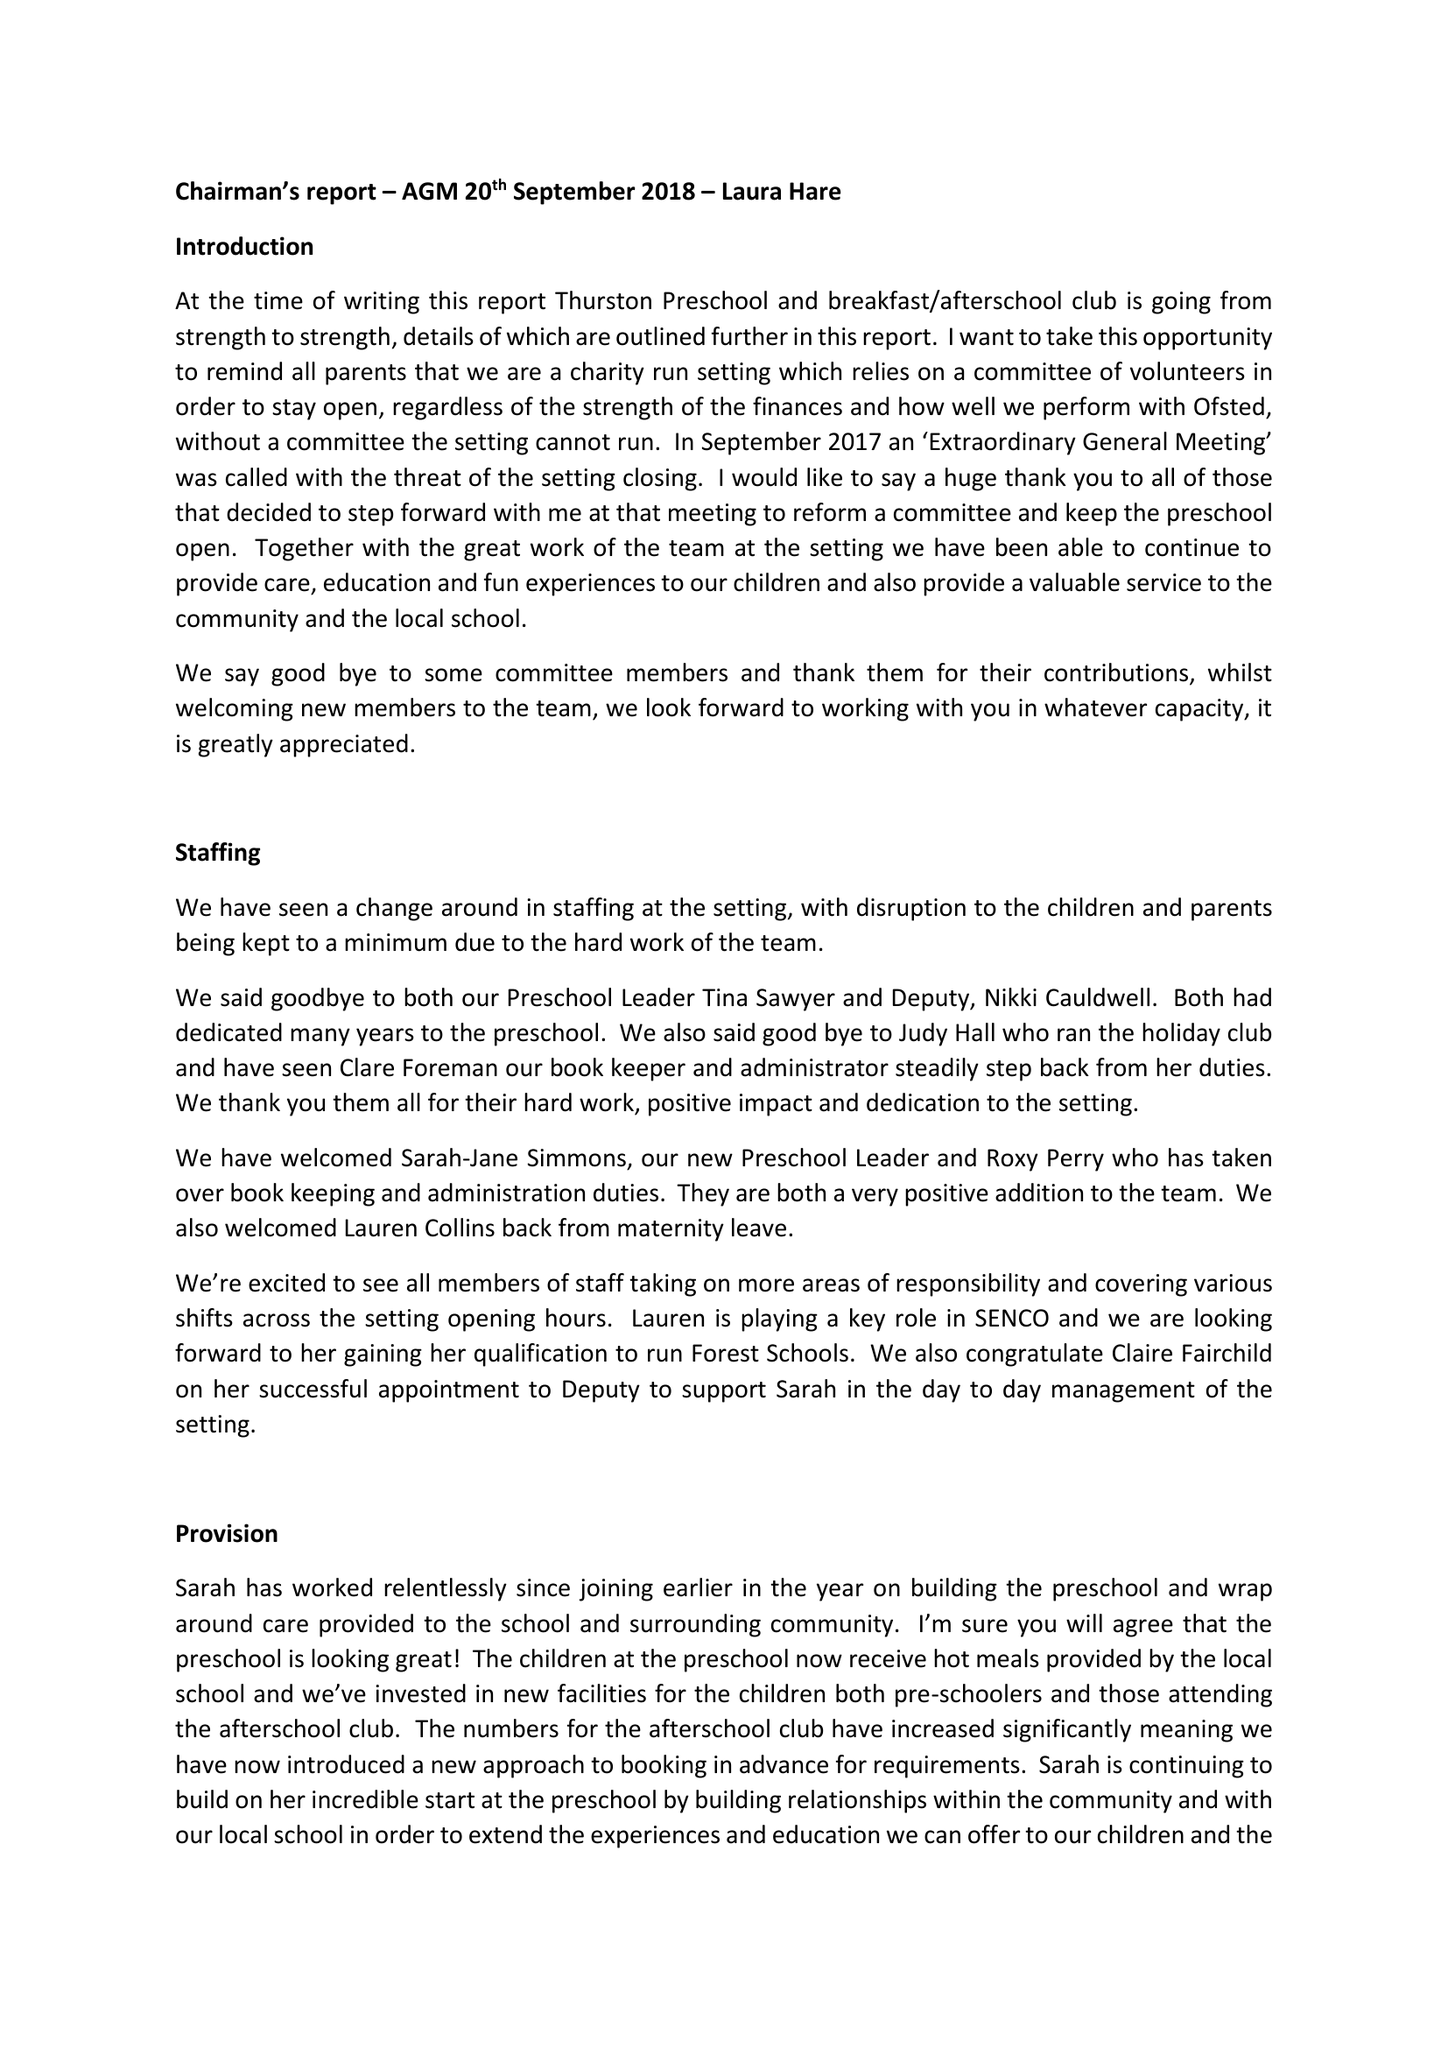What is the value for the charity_name?
Answer the question using a single word or phrase. Thurston Pre-School Ltd. 